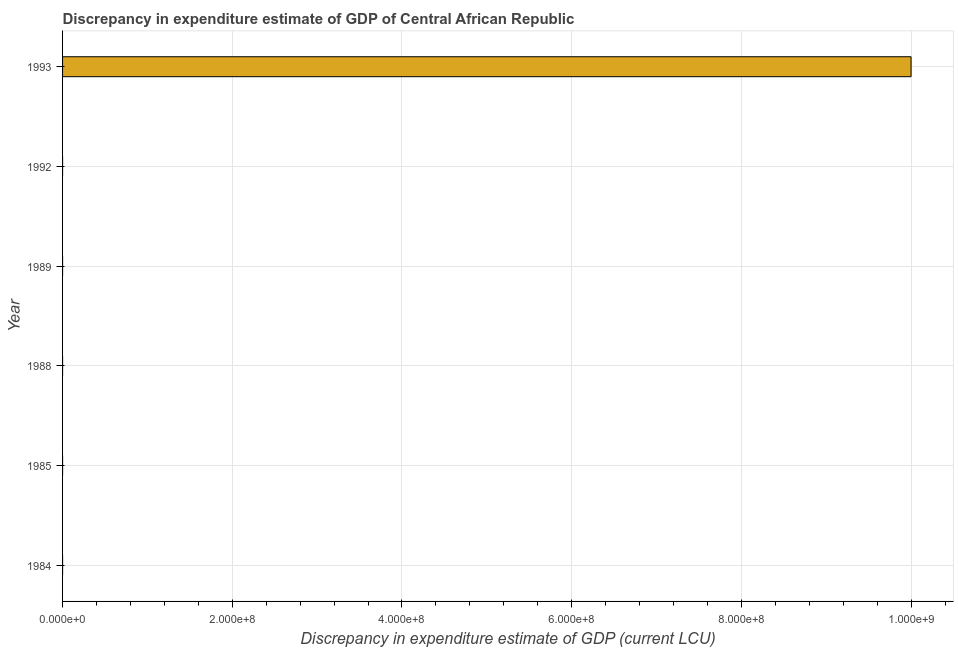Does the graph contain grids?
Provide a short and direct response. Yes. What is the title of the graph?
Offer a very short reply. Discrepancy in expenditure estimate of GDP of Central African Republic. What is the label or title of the X-axis?
Provide a succinct answer. Discrepancy in expenditure estimate of GDP (current LCU). What is the label or title of the Y-axis?
Offer a terse response. Year. What is the discrepancy in expenditure estimate of gdp in 1984?
Offer a very short reply. 4e-6. Across all years, what is the maximum discrepancy in expenditure estimate of gdp?
Ensure brevity in your answer.  1.00e+09. What is the sum of the discrepancy in expenditure estimate of gdp?
Your answer should be very brief. 1.00e+09. What is the difference between the discrepancy in expenditure estimate of gdp in 1985 and 1989?
Make the answer very short. -0. What is the average discrepancy in expenditure estimate of gdp per year?
Your answer should be compact. 1.67e+08. What is the median discrepancy in expenditure estimate of gdp?
Give a very brief answer. 2.8e-5. In how many years, is the discrepancy in expenditure estimate of gdp greater than 560000000 LCU?
Give a very brief answer. 1. What is the ratio of the discrepancy in expenditure estimate of gdp in 1984 to that in 1989?
Ensure brevity in your answer.  0.07. Is the discrepancy in expenditure estimate of gdp in 1984 less than that in 1989?
Offer a terse response. Yes. Is the difference between the discrepancy in expenditure estimate of gdp in 1985 and 1989 greater than the difference between any two years?
Your answer should be compact. No. What is the difference between the highest and the second highest discrepancy in expenditure estimate of gdp?
Offer a terse response. 1.00e+09. How many bars are there?
Provide a short and direct response. 4. How many years are there in the graph?
Provide a succinct answer. 6. What is the difference between two consecutive major ticks on the X-axis?
Your answer should be compact. 2.00e+08. Are the values on the major ticks of X-axis written in scientific E-notation?
Provide a succinct answer. Yes. What is the Discrepancy in expenditure estimate of GDP (current LCU) of 1984?
Provide a succinct answer. 4e-6. What is the Discrepancy in expenditure estimate of GDP (current LCU) of 1985?
Offer a very short reply. 5.2e-5. What is the Discrepancy in expenditure estimate of GDP (current LCU) of 1989?
Offer a very short reply. 6e-5. What is the Discrepancy in expenditure estimate of GDP (current LCU) in 1992?
Offer a very short reply. 0. What is the Discrepancy in expenditure estimate of GDP (current LCU) in 1993?
Your answer should be very brief. 1.00e+09. What is the difference between the Discrepancy in expenditure estimate of GDP (current LCU) in 1984 and 1985?
Ensure brevity in your answer.  -5e-5. What is the difference between the Discrepancy in expenditure estimate of GDP (current LCU) in 1984 and 1989?
Your response must be concise. -6e-5. What is the difference between the Discrepancy in expenditure estimate of GDP (current LCU) in 1984 and 1993?
Your answer should be very brief. -1.00e+09. What is the difference between the Discrepancy in expenditure estimate of GDP (current LCU) in 1985 and 1989?
Ensure brevity in your answer.  -1e-5. What is the difference between the Discrepancy in expenditure estimate of GDP (current LCU) in 1985 and 1993?
Your answer should be compact. -1.00e+09. What is the difference between the Discrepancy in expenditure estimate of GDP (current LCU) in 1989 and 1993?
Give a very brief answer. -1.00e+09. What is the ratio of the Discrepancy in expenditure estimate of GDP (current LCU) in 1984 to that in 1985?
Give a very brief answer. 0.08. What is the ratio of the Discrepancy in expenditure estimate of GDP (current LCU) in 1984 to that in 1989?
Keep it short and to the point. 0.07. What is the ratio of the Discrepancy in expenditure estimate of GDP (current LCU) in 1984 to that in 1993?
Your response must be concise. 0. What is the ratio of the Discrepancy in expenditure estimate of GDP (current LCU) in 1985 to that in 1989?
Keep it short and to the point. 0.87. What is the ratio of the Discrepancy in expenditure estimate of GDP (current LCU) in 1989 to that in 1993?
Your answer should be very brief. 0. 